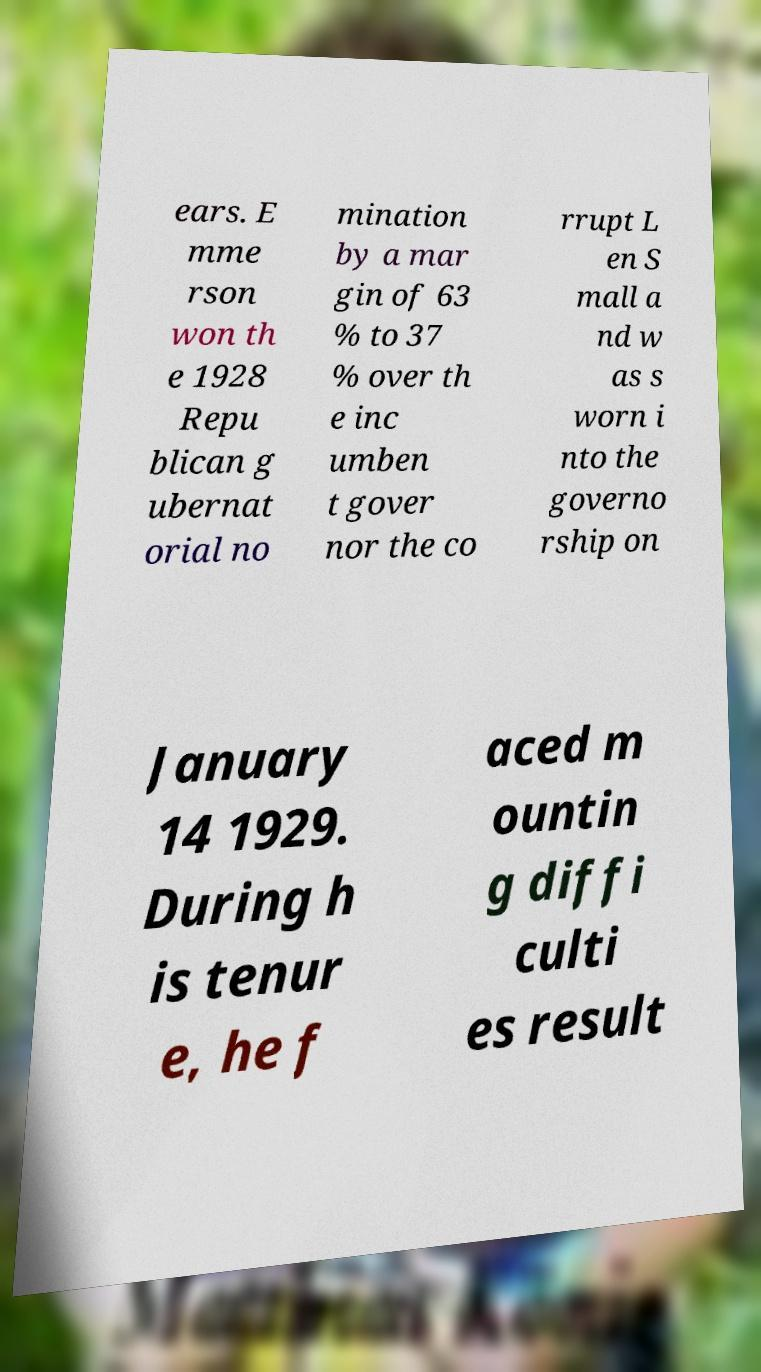For documentation purposes, I need the text within this image transcribed. Could you provide that? ears. E mme rson won th e 1928 Repu blican g ubernat orial no mination by a mar gin of 63 % to 37 % over th e inc umben t gover nor the co rrupt L en S mall a nd w as s worn i nto the governo rship on January 14 1929. During h is tenur e, he f aced m ountin g diffi culti es result 